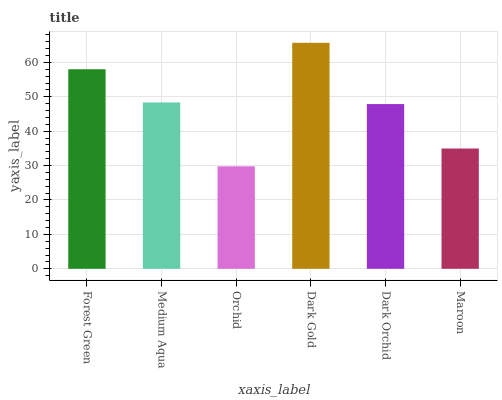Is Orchid the minimum?
Answer yes or no. Yes. Is Dark Gold the maximum?
Answer yes or no. Yes. Is Medium Aqua the minimum?
Answer yes or no. No. Is Medium Aqua the maximum?
Answer yes or no. No. Is Forest Green greater than Medium Aqua?
Answer yes or no. Yes. Is Medium Aqua less than Forest Green?
Answer yes or no. Yes. Is Medium Aqua greater than Forest Green?
Answer yes or no. No. Is Forest Green less than Medium Aqua?
Answer yes or no. No. Is Medium Aqua the high median?
Answer yes or no. Yes. Is Dark Orchid the low median?
Answer yes or no. Yes. Is Maroon the high median?
Answer yes or no. No. Is Maroon the low median?
Answer yes or no. No. 